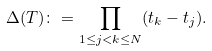<formula> <loc_0><loc_0><loc_500><loc_500>\Delta ( T ) \colon = \prod _ { 1 \leq j < k \leq N } ( t _ { k } - t _ { j } ) .</formula> 